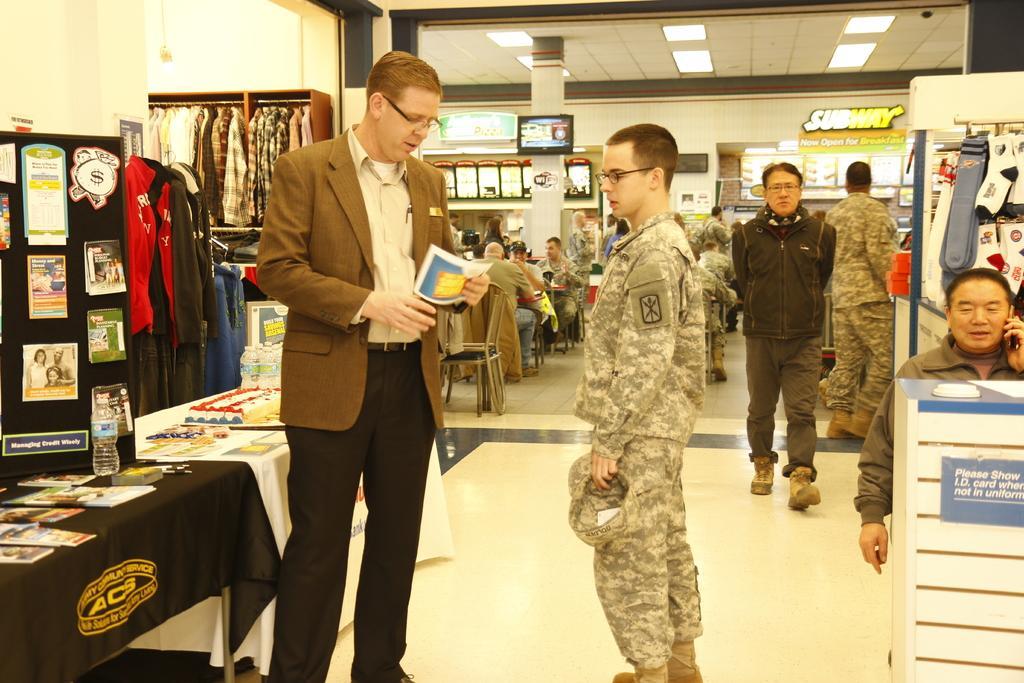Could you give a brief overview of what you see in this image? In this picture there are people and we can see bottles, books, board and objects on tables. We can see clothes, posters on a board, socks, wall and objects. In the background of the image we can see people, chairs, boards and television on a pillar. At the top of the image we can see lights and ceiling. 